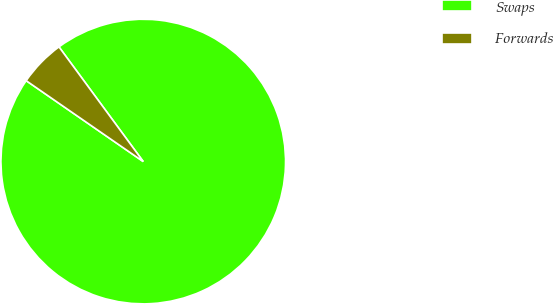<chart> <loc_0><loc_0><loc_500><loc_500><pie_chart><fcel>Swaps<fcel>Forwards<nl><fcel>94.71%<fcel>5.29%<nl></chart> 